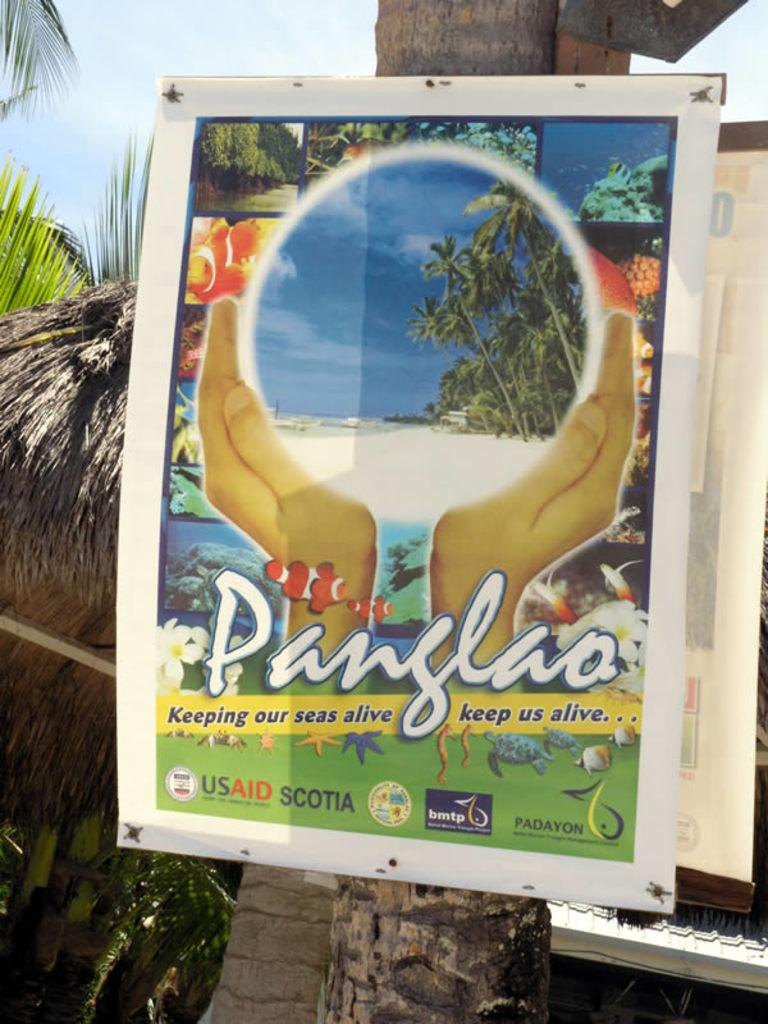What is attached to the tree trunk in the image? There is a poster on the tree trunk. What can be seen in the background of the image? The sky is visible in the background of the image. Can you describe the person standing behind the tree in the image? There is no person standing behind the tree in the image. 